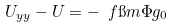<formula> <loc_0><loc_0><loc_500><loc_500>U _ { y y } - U = - \ f { \i m \Phi } { g _ { 0 } }</formula> 